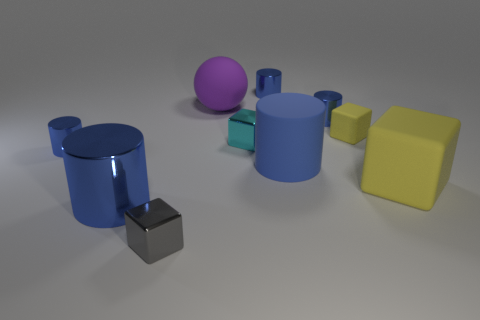Subtract all big cylinders. How many cylinders are left? 3 Subtract all cyan cubes. How many cubes are left? 3 Subtract 4 cubes. How many cubes are left? 0 Subtract all gray cylinders. How many yellow cubes are left? 2 Add 1 shiny objects. How many shiny objects are left? 7 Add 1 gray objects. How many gray objects exist? 2 Subtract 0 yellow cylinders. How many objects are left? 10 Subtract all spheres. How many objects are left? 9 Subtract all red cylinders. Subtract all yellow blocks. How many cylinders are left? 5 Subtract all tiny blue metal cylinders. Subtract all large blue shiny things. How many objects are left? 6 